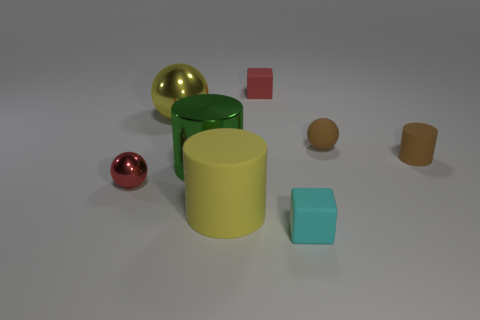Subtract all yellow rubber cylinders. How many cylinders are left? 2 Add 2 large yellow balls. How many objects exist? 10 Subtract all cyan cylinders. Subtract all blue balls. How many cylinders are left? 3 Subtract all spheres. How many objects are left? 5 Subtract 0 gray cylinders. How many objects are left? 8 Subtract all tiny purple matte cylinders. Subtract all yellow rubber objects. How many objects are left? 7 Add 3 tiny brown matte cylinders. How many tiny brown matte cylinders are left? 4 Add 5 tiny purple metal balls. How many tiny purple metal balls exist? 5 